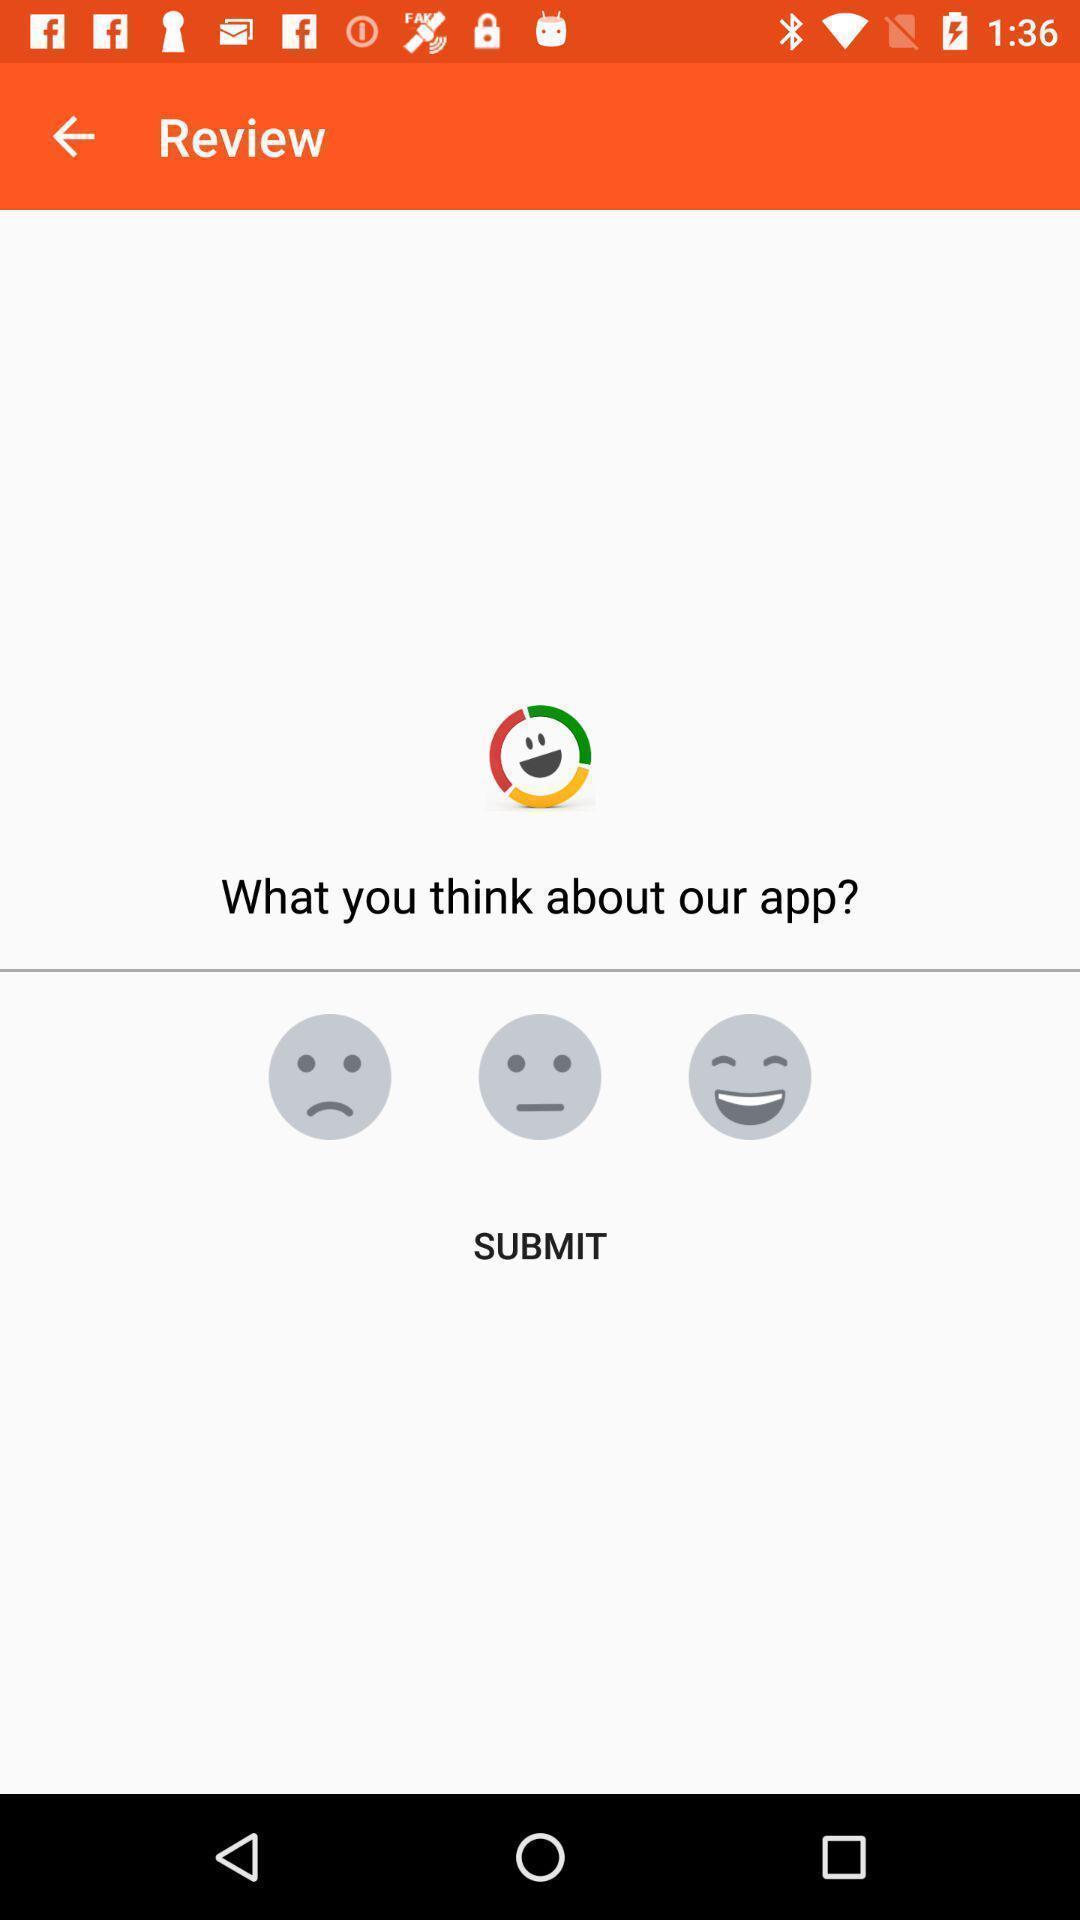Explain the elements present in this screenshot. Screen page showing various emojis to rate an app. 